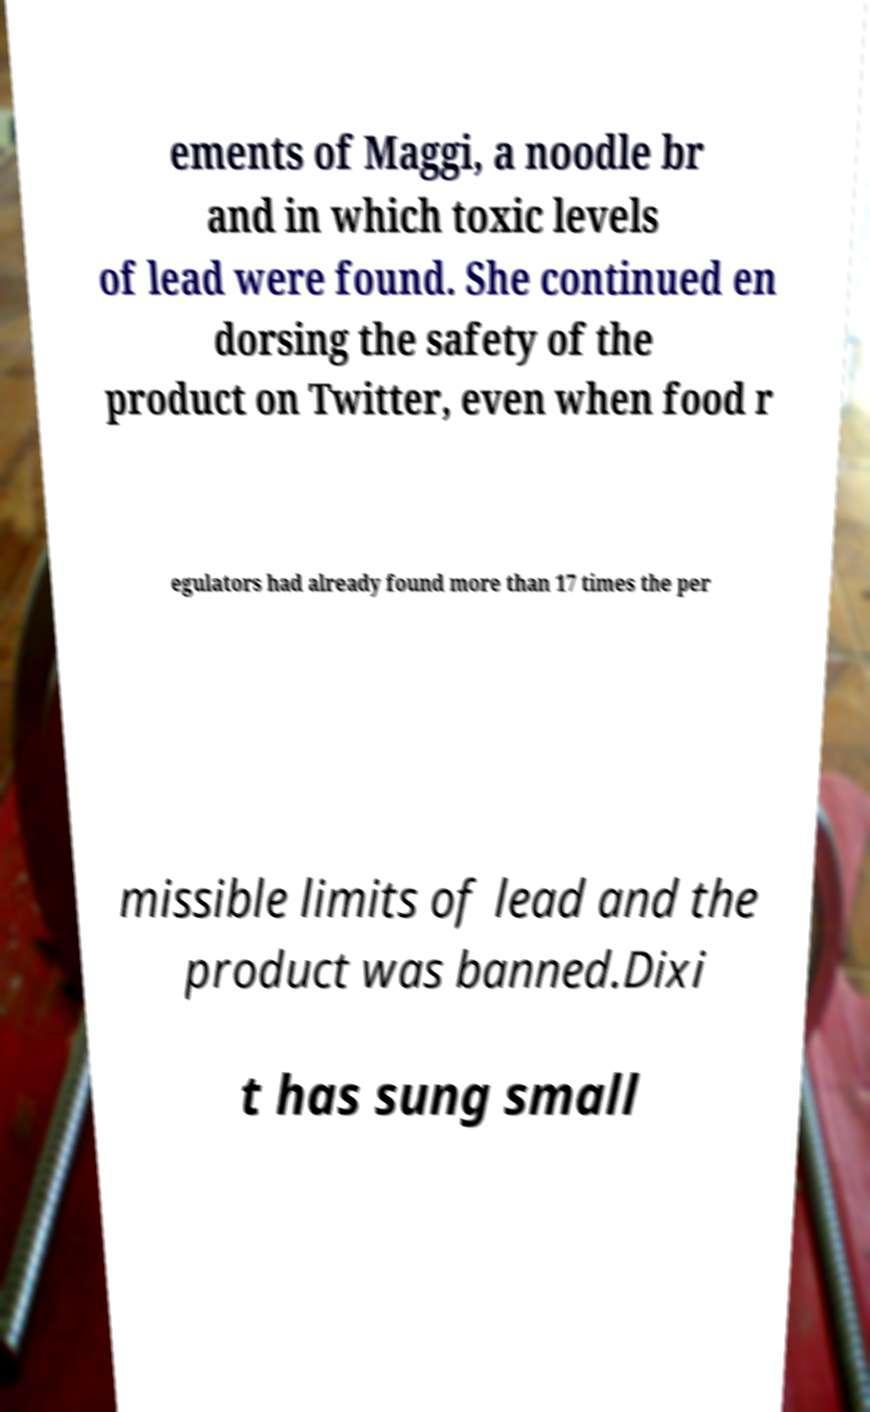There's text embedded in this image that I need extracted. Can you transcribe it verbatim? ements of Maggi, a noodle br and in which toxic levels of lead were found. She continued en dorsing the safety of the product on Twitter, even when food r egulators had already found more than 17 times the per missible limits of lead and the product was banned.Dixi t has sung small 